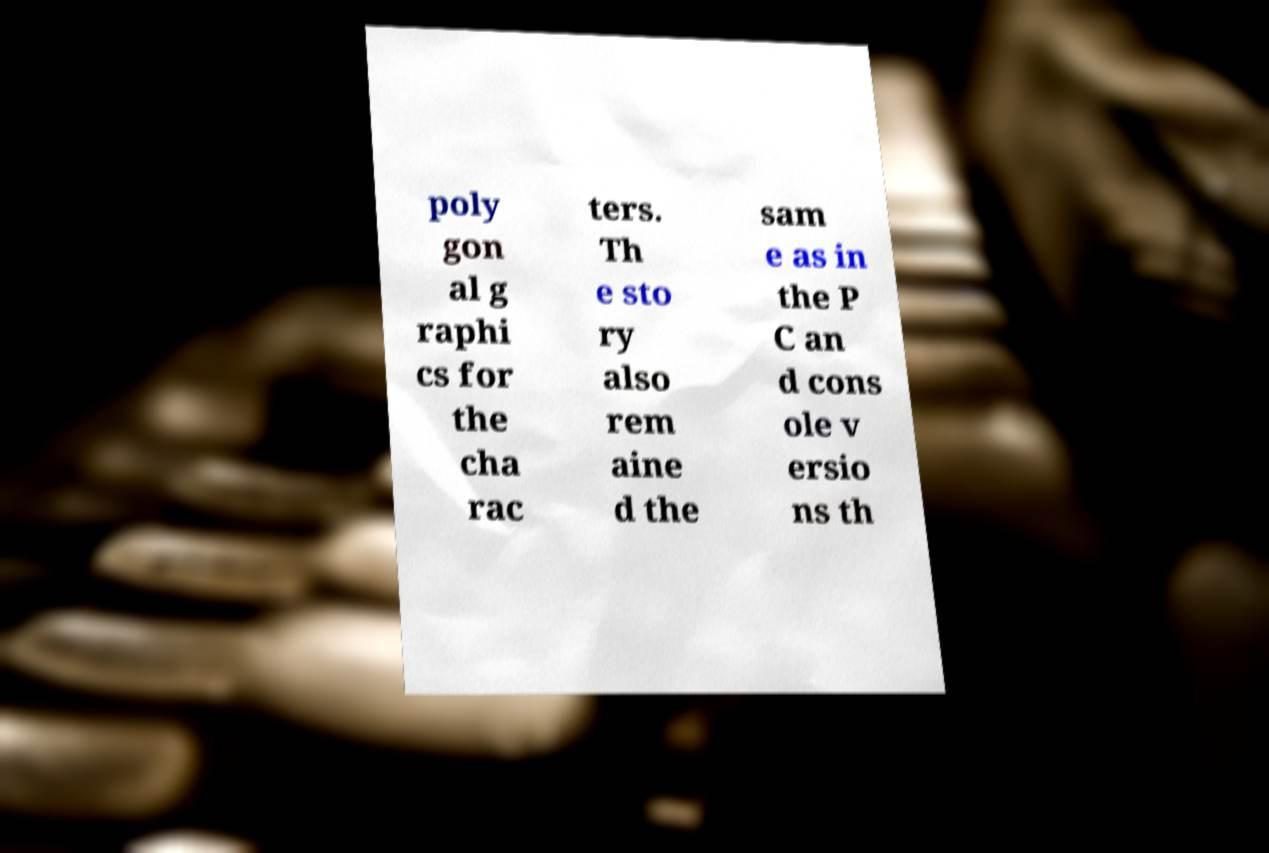I need the written content from this picture converted into text. Can you do that? poly gon al g raphi cs for the cha rac ters. Th e sto ry also rem aine d the sam e as in the P C an d cons ole v ersio ns th 